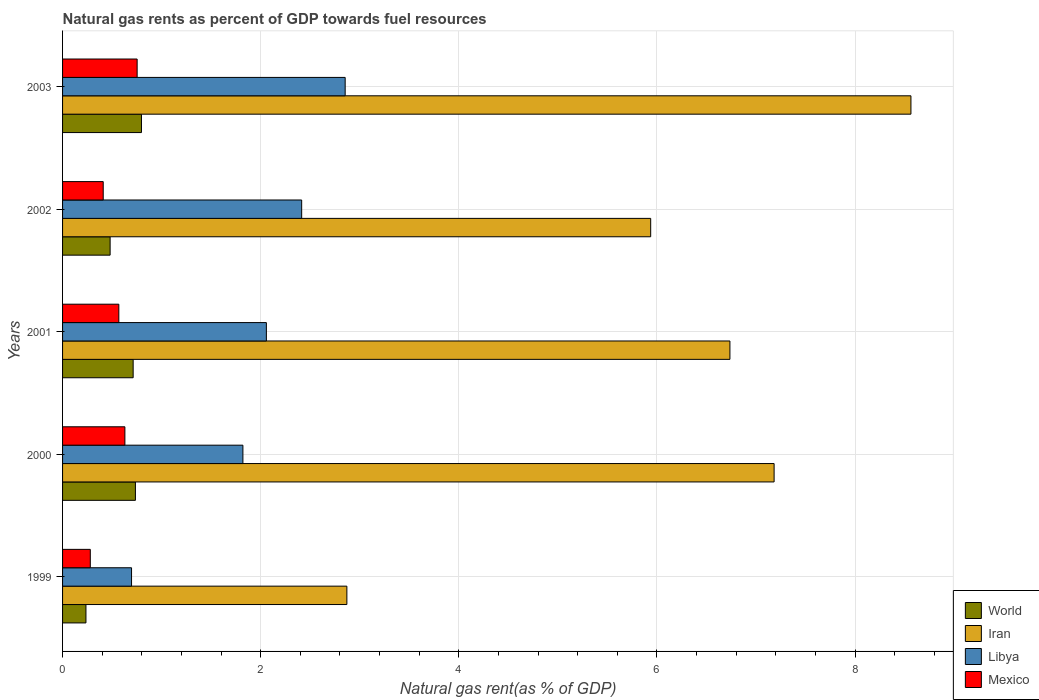Are the number of bars per tick equal to the number of legend labels?
Offer a terse response. Yes. Are the number of bars on each tick of the Y-axis equal?
Keep it short and to the point. Yes. What is the natural gas rent in Iran in 2003?
Make the answer very short. 8.56. Across all years, what is the maximum natural gas rent in Libya?
Your answer should be very brief. 2.85. Across all years, what is the minimum natural gas rent in World?
Your response must be concise. 0.24. In which year was the natural gas rent in Libya minimum?
Ensure brevity in your answer.  1999. What is the total natural gas rent in Iran in the graph?
Your answer should be compact. 31.29. What is the difference between the natural gas rent in Libya in 1999 and that in 2000?
Keep it short and to the point. -1.12. What is the difference between the natural gas rent in Libya in 2000 and the natural gas rent in World in 2001?
Offer a very short reply. 1.11. What is the average natural gas rent in World per year?
Provide a short and direct response. 0.59. In the year 2002, what is the difference between the natural gas rent in Libya and natural gas rent in Iran?
Ensure brevity in your answer.  -3.52. In how many years, is the natural gas rent in Libya greater than 4 %?
Offer a terse response. 0. What is the ratio of the natural gas rent in World in 1999 to that in 2001?
Offer a very short reply. 0.33. Is the natural gas rent in World in 2001 less than that in 2002?
Ensure brevity in your answer.  No. Is the difference between the natural gas rent in Libya in 2000 and 2002 greater than the difference between the natural gas rent in Iran in 2000 and 2002?
Give a very brief answer. No. What is the difference between the highest and the second highest natural gas rent in Iran?
Provide a succinct answer. 1.38. What is the difference between the highest and the lowest natural gas rent in Libya?
Provide a short and direct response. 2.16. Is the sum of the natural gas rent in Libya in 2000 and 2003 greater than the maximum natural gas rent in World across all years?
Make the answer very short. Yes. What does the 2nd bar from the top in 2003 represents?
Provide a short and direct response. Libya. Is it the case that in every year, the sum of the natural gas rent in Iran and natural gas rent in World is greater than the natural gas rent in Mexico?
Your answer should be very brief. Yes. How many bars are there?
Ensure brevity in your answer.  20. How many years are there in the graph?
Offer a terse response. 5. Does the graph contain any zero values?
Your answer should be very brief. No. Does the graph contain grids?
Ensure brevity in your answer.  Yes. How many legend labels are there?
Your answer should be very brief. 4. How are the legend labels stacked?
Ensure brevity in your answer.  Vertical. What is the title of the graph?
Keep it short and to the point. Natural gas rents as percent of GDP towards fuel resources. Does "Bangladesh" appear as one of the legend labels in the graph?
Your response must be concise. No. What is the label or title of the X-axis?
Keep it short and to the point. Natural gas rent(as % of GDP). What is the Natural gas rent(as % of GDP) in World in 1999?
Ensure brevity in your answer.  0.24. What is the Natural gas rent(as % of GDP) in Iran in 1999?
Your response must be concise. 2.87. What is the Natural gas rent(as % of GDP) of Libya in 1999?
Keep it short and to the point. 0.7. What is the Natural gas rent(as % of GDP) of Mexico in 1999?
Your answer should be very brief. 0.28. What is the Natural gas rent(as % of GDP) in World in 2000?
Your answer should be very brief. 0.74. What is the Natural gas rent(as % of GDP) in Iran in 2000?
Make the answer very short. 7.18. What is the Natural gas rent(as % of GDP) of Libya in 2000?
Your response must be concise. 1.82. What is the Natural gas rent(as % of GDP) in Mexico in 2000?
Give a very brief answer. 0.63. What is the Natural gas rent(as % of GDP) of World in 2001?
Your response must be concise. 0.71. What is the Natural gas rent(as % of GDP) of Iran in 2001?
Give a very brief answer. 6.74. What is the Natural gas rent(as % of GDP) of Libya in 2001?
Make the answer very short. 2.06. What is the Natural gas rent(as % of GDP) of Mexico in 2001?
Keep it short and to the point. 0.57. What is the Natural gas rent(as % of GDP) of World in 2002?
Give a very brief answer. 0.48. What is the Natural gas rent(as % of GDP) of Iran in 2002?
Keep it short and to the point. 5.94. What is the Natural gas rent(as % of GDP) of Libya in 2002?
Provide a succinct answer. 2.41. What is the Natural gas rent(as % of GDP) of Mexico in 2002?
Provide a succinct answer. 0.41. What is the Natural gas rent(as % of GDP) in World in 2003?
Provide a short and direct response. 0.8. What is the Natural gas rent(as % of GDP) of Iran in 2003?
Ensure brevity in your answer.  8.56. What is the Natural gas rent(as % of GDP) in Libya in 2003?
Ensure brevity in your answer.  2.85. What is the Natural gas rent(as % of GDP) of Mexico in 2003?
Your answer should be very brief. 0.75. Across all years, what is the maximum Natural gas rent(as % of GDP) in World?
Ensure brevity in your answer.  0.8. Across all years, what is the maximum Natural gas rent(as % of GDP) in Iran?
Your response must be concise. 8.56. Across all years, what is the maximum Natural gas rent(as % of GDP) in Libya?
Your answer should be very brief. 2.85. Across all years, what is the maximum Natural gas rent(as % of GDP) of Mexico?
Your response must be concise. 0.75. Across all years, what is the minimum Natural gas rent(as % of GDP) of World?
Your answer should be very brief. 0.24. Across all years, what is the minimum Natural gas rent(as % of GDP) in Iran?
Offer a terse response. 2.87. Across all years, what is the minimum Natural gas rent(as % of GDP) in Libya?
Your answer should be compact. 0.7. Across all years, what is the minimum Natural gas rent(as % of GDP) of Mexico?
Keep it short and to the point. 0.28. What is the total Natural gas rent(as % of GDP) of World in the graph?
Ensure brevity in your answer.  2.96. What is the total Natural gas rent(as % of GDP) of Iran in the graph?
Offer a terse response. 31.29. What is the total Natural gas rent(as % of GDP) of Libya in the graph?
Your response must be concise. 9.84. What is the total Natural gas rent(as % of GDP) of Mexico in the graph?
Make the answer very short. 2.64. What is the difference between the Natural gas rent(as % of GDP) in World in 1999 and that in 2000?
Keep it short and to the point. -0.5. What is the difference between the Natural gas rent(as % of GDP) of Iran in 1999 and that in 2000?
Make the answer very short. -4.31. What is the difference between the Natural gas rent(as % of GDP) in Libya in 1999 and that in 2000?
Keep it short and to the point. -1.12. What is the difference between the Natural gas rent(as % of GDP) of Mexico in 1999 and that in 2000?
Keep it short and to the point. -0.35. What is the difference between the Natural gas rent(as % of GDP) in World in 1999 and that in 2001?
Offer a very short reply. -0.48. What is the difference between the Natural gas rent(as % of GDP) of Iran in 1999 and that in 2001?
Give a very brief answer. -3.87. What is the difference between the Natural gas rent(as % of GDP) in Libya in 1999 and that in 2001?
Provide a succinct answer. -1.36. What is the difference between the Natural gas rent(as % of GDP) of Mexico in 1999 and that in 2001?
Give a very brief answer. -0.29. What is the difference between the Natural gas rent(as % of GDP) in World in 1999 and that in 2002?
Offer a very short reply. -0.24. What is the difference between the Natural gas rent(as % of GDP) of Iran in 1999 and that in 2002?
Your answer should be very brief. -3.07. What is the difference between the Natural gas rent(as % of GDP) in Libya in 1999 and that in 2002?
Provide a succinct answer. -1.72. What is the difference between the Natural gas rent(as % of GDP) of Mexico in 1999 and that in 2002?
Provide a short and direct response. -0.13. What is the difference between the Natural gas rent(as % of GDP) of World in 1999 and that in 2003?
Make the answer very short. -0.56. What is the difference between the Natural gas rent(as % of GDP) of Iran in 1999 and that in 2003?
Your response must be concise. -5.69. What is the difference between the Natural gas rent(as % of GDP) of Libya in 1999 and that in 2003?
Give a very brief answer. -2.16. What is the difference between the Natural gas rent(as % of GDP) of Mexico in 1999 and that in 2003?
Provide a succinct answer. -0.47. What is the difference between the Natural gas rent(as % of GDP) in World in 2000 and that in 2001?
Ensure brevity in your answer.  0.02. What is the difference between the Natural gas rent(as % of GDP) in Iran in 2000 and that in 2001?
Keep it short and to the point. 0.45. What is the difference between the Natural gas rent(as % of GDP) of Libya in 2000 and that in 2001?
Ensure brevity in your answer.  -0.24. What is the difference between the Natural gas rent(as % of GDP) of Mexico in 2000 and that in 2001?
Offer a terse response. 0.06. What is the difference between the Natural gas rent(as % of GDP) of World in 2000 and that in 2002?
Offer a very short reply. 0.26. What is the difference between the Natural gas rent(as % of GDP) in Iran in 2000 and that in 2002?
Ensure brevity in your answer.  1.25. What is the difference between the Natural gas rent(as % of GDP) in Libya in 2000 and that in 2002?
Your answer should be very brief. -0.59. What is the difference between the Natural gas rent(as % of GDP) of Mexico in 2000 and that in 2002?
Offer a terse response. 0.22. What is the difference between the Natural gas rent(as % of GDP) of World in 2000 and that in 2003?
Offer a terse response. -0.06. What is the difference between the Natural gas rent(as % of GDP) in Iran in 2000 and that in 2003?
Your response must be concise. -1.38. What is the difference between the Natural gas rent(as % of GDP) of Libya in 2000 and that in 2003?
Your answer should be compact. -1.03. What is the difference between the Natural gas rent(as % of GDP) in Mexico in 2000 and that in 2003?
Offer a terse response. -0.12. What is the difference between the Natural gas rent(as % of GDP) of World in 2001 and that in 2002?
Your answer should be compact. 0.23. What is the difference between the Natural gas rent(as % of GDP) in Iran in 2001 and that in 2002?
Give a very brief answer. 0.8. What is the difference between the Natural gas rent(as % of GDP) of Libya in 2001 and that in 2002?
Your answer should be compact. -0.36. What is the difference between the Natural gas rent(as % of GDP) of Mexico in 2001 and that in 2002?
Offer a very short reply. 0.16. What is the difference between the Natural gas rent(as % of GDP) in World in 2001 and that in 2003?
Provide a succinct answer. -0.08. What is the difference between the Natural gas rent(as % of GDP) in Iran in 2001 and that in 2003?
Make the answer very short. -1.83. What is the difference between the Natural gas rent(as % of GDP) of Libya in 2001 and that in 2003?
Give a very brief answer. -0.8. What is the difference between the Natural gas rent(as % of GDP) in Mexico in 2001 and that in 2003?
Keep it short and to the point. -0.18. What is the difference between the Natural gas rent(as % of GDP) of World in 2002 and that in 2003?
Offer a terse response. -0.32. What is the difference between the Natural gas rent(as % of GDP) in Iran in 2002 and that in 2003?
Keep it short and to the point. -2.63. What is the difference between the Natural gas rent(as % of GDP) of Libya in 2002 and that in 2003?
Provide a short and direct response. -0.44. What is the difference between the Natural gas rent(as % of GDP) in Mexico in 2002 and that in 2003?
Offer a very short reply. -0.34. What is the difference between the Natural gas rent(as % of GDP) of World in 1999 and the Natural gas rent(as % of GDP) of Iran in 2000?
Your answer should be very brief. -6.95. What is the difference between the Natural gas rent(as % of GDP) of World in 1999 and the Natural gas rent(as % of GDP) of Libya in 2000?
Provide a short and direct response. -1.58. What is the difference between the Natural gas rent(as % of GDP) in World in 1999 and the Natural gas rent(as % of GDP) in Mexico in 2000?
Ensure brevity in your answer.  -0.39. What is the difference between the Natural gas rent(as % of GDP) of Iran in 1999 and the Natural gas rent(as % of GDP) of Libya in 2000?
Ensure brevity in your answer.  1.05. What is the difference between the Natural gas rent(as % of GDP) of Iran in 1999 and the Natural gas rent(as % of GDP) of Mexico in 2000?
Ensure brevity in your answer.  2.24. What is the difference between the Natural gas rent(as % of GDP) in Libya in 1999 and the Natural gas rent(as % of GDP) in Mexico in 2000?
Keep it short and to the point. 0.07. What is the difference between the Natural gas rent(as % of GDP) in World in 1999 and the Natural gas rent(as % of GDP) in Iran in 2001?
Keep it short and to the point. -6.5. What is the difference between the Natural gas rent(as % of GDP) of World in 1999 and the Natural gas rent(as % of GDP) of Libya in 2001?
Your response must be concise. -1.82. What is the difference between the Natural gas rent(as % of GDP) of World in 1999 and the Natural gas rent(as % of GDP) of Mexico in 2001?
Ensure brevity in your answer.  -0.33. What is the difference between the Natural gas rent(as % of GDP) of Iran in 1999 and the Natural gas rent(as % of GDP) of Libya in 2001?
Give a very brief answer. 0.81. What is the difference between the Natural gas rent(as % of GDP) in Iran in 1999 and the Natural gas rent(as % of GDP) in Mexico in 2001?
Your answer should be very brief. 2.3. What is the difference between the Natural gas rent(as % of GDP) of Libya in 1999 and the Natural gas rent(as % of GDP) of Mexico in 2001?
Provide a succinct answer. 0.13. What is the difference between the Natural gas rent(as % of GDP) of World in 1999 and the Natural gas rent(as % of GDP) of Iran in 2002?
Make the answer very short. -5.7. What is the difference between the Natural gas rent(as % of GDP) of World in 1999 and the Natural gas rent(as % of GDP) of Libya in 2002?
Give a very brief answer. -2.18. What is the difference between the Natural gas rent(as % of GDP) of World in 1999 and the Natural gas rent(as % of GDP) of Mexico in 2002?
Provide a short and direct response. -0.17. What is the difference between the Natural gas rent(as % of GDP) of Iran in 1999 and the Natural gas rent(as % of GDP) of Libya in 2002?
Offer a very short reply. 0.46. What is the difference between the Natural gas rent(as % of GDP) of Iran in 1999 and the Natural gas rent(as % of GDP) of Mexico in 2002?
Your response must be concise. 2.46. What is the difference between the Natural gas rent(as % of GDP) in Libya in 1999 and the Natural gas rent(as % of GDP) in Mexico in 2002?
Ensure brevity in your answer.  0.29. What is the difference between the Natural gas rent(as % of GDP) in World in 1999 and the Natural gas rent(as % of GDP) in Iran in 2003?
Keep it short and to the point. -8.33. What is the difference between the Natural gas rent(as % of GDP) in World in 1999 and the Natural gas rent(as % of GDP) in Libya in 2003?
Offer a very short reply. -2.62. What is the difference between the Natural gas rent(as % of GDP) of World in 1999 and the Natural gas rent(as % of GDP) of Mexico in 2003?
Provide a short and direct response. -0.52. What is the difference between the Natural gas rent(as % of GDP) of Iran in 1999 and the Natural gas rent(as % of GDP) of Libya in 2003?
Ensure brevity in your answer.  0.02. What is the difference between the Natural gas rent(as % of GDP) in Iran in 1999 and the Natural gas rent(as % of GDP) in Mexico in 2003?
Offer a terse response. 2.12. What is the difference between the Natural gas rent(as % of GDP) of Libya in 1999 and the Natural gas rent(as % of GDP) of Mexico in 2003?
Your answer should be compact. -0.06. What is the difference between the Natural gas rent(as % of GDP) of World in 2000 and the Natural gas rent(as % of GDP) of Iran in 2001?
Offer a very short reply. -6. What is the difference between the Natural gas rent(as % of GDP) of World in 2000 and the Natural gas rent(as % of GDP) of Libya in 2001?
Ensure brevity in your answer.  -1.32. What is the difference between the Natural gas rent(as % of GDP) of World in 2000 and the Natural gas rent(as % of GDP) of Mexico in 2001?
Keep it short and to the point. 0.17. What is the difference between the Natural gas rent(as % of GDP) of Iran in 2000 and the Natural gas rent(as % of GDP) of Libya in 2001?
Keep it short and to the point. 5.13. What is the difference between the Natural gas rent(as % of GDP) of Iran in 2000 and the Natural gas rent(as % of GDP) of Mexico in 2001?
Make the answer very short. 6.62. What is the difference between the Natural gas rent(as % of GDP) of Libya in 2000 and the Natural gas rent(as % of GDP) of Mexico in 2001?
Your answer should be compact. 1.25. What is the difference between the Natural gas rent(as % of GDP) in World in 2000 and the Natural gas rent(as % of GDP) in Iran in 2002?
Give a very brief answer. -5.2. What is the difference between the Natural gas rent(as % of GDP) of World in 2000 and the Natural gas rent(as % of GDP) of Libya in 2002?
Provide a succinct answer. -1.68. What is the difference between the Natural gas rent(as % of GDP) in World in 2000 and the Natural gas rent(as % of GDP) in Mexico in 2002?
Provide a short and direct response. 0.33. What is the difference between the Natural gas rent(as % of GDP) in Iran in 2000 and the Natural gas rent(as % of GDP) in Libya in 2002?
Your answer should be compact. 4.77. What is the difference between the Natural gas rent(as % of GDP) of Iran in 2000 and the Natural gas rent(as % of GDP) of Mexico in 2002?
Offer a very short reply. 6.77. What is the difference between the Natural gas rent(as % of GDP) in Libya in 2000 and the Natural gas rent(as % of GDP) in Mexico in 2002?
Offer a terse response. 1.41. What is the difference between the Natural gas rent(as % of GDP) in World in 2000 and the Natural gas rent(as % of GDP) in Iran in 2003?
Your response must be concise. -7.83. What is the difference between the Natural gas rent(as % of GDP) of World in 2000 and the Natural gas rent(as % of GDP) of Libya in 2003?
Offer a terse response. -2.12. What is the difference between the Natural gas rent(as % of GDP) in World in 2000 and the Natural gas rent(as % of GDP) in Mexico in 2003?
Keep it short and to the point. -0.02. What is the difference between the Natural gas rent(as % of GDP) in Iran in 2000 and the Natural gas rent(as % of GDP) in Libya in 2003?
Ensure brevity in your answer.  4.33. What is the difference between the Natural gas rent(as % of GDP) of Iran in 2000 and the Natural gas rent(as % of GDP) of Mexico in 2003?
Keep it short and to the point. 6.43. What is the difference between the Natural gas rent(as % of GDP) of Libya in 2000 and the Natural gas rent(as % of GDP) of Mexico in 2003?
Your answer should be very brief. 1.07. What is the difference between the Natural gas rent(as % of GDP) in World in 2001 and the Natural gas rent(as % of GDP) in Iran in 2002?
Keep it short and to the point. -5.22. What is the difference between the Natural gas rent(as % of GDP) of World in 2001 and the Natural gas rent(as % of GDP) of Libya in 2002?
Provide a short and direct response. -1.7. What is the difference between the Natural gas rent(as % of GDP) in World in 2001 and the Natural gas rent(as % of GDP) in Mexico in 2002?
Give a very brief answer. 0.3. What is the difference between the Natural gas rent(as % of GDP) of Iran in 2001 and the Natural gas rent(as % of GDP) of Libya in 2002?
Ensure brevity in your answer.  4.32. What is the difference between the Natural gas rent(as % of GDP) of Iran in 2001 and the Natural gas rent(as % of GDP) of Mexico in 2002?
Offer a very short reply. 6.33. What is the difference between the Natural gas rent(as % of GDP) of Libya in 2001 and the Natural gas rent(as % of GDP) of Mexico in 2002?
Keep it short and to the point. 1.65. What is the difference between the Natural gas rent(as % of GDP) of World in 2001 and the Natural gas rent(as % of GDP) of Iran in 2003?
Give a very brief answer. -7.85. What is the difference between the Natural gas rent(as % of GDP) of World in 2001 and the Natural gas rent(as % of GDP) of Libya in 2003?
Make the answer very short. -2.14. What is the difference between the Natural gas rent(as % of GDP) of World in 2001 and the Natural gas rent(as % of GDP) of Mexico in 2003?
Your response must be concise. -0.04. What is the difference between the Natural gas rent(as % of GDP) in Iran in 2001 and the Natural gas rent(as % of GDP) in Libya in 2003?
Offer a terse response. 3.88. What is the difference between the Natural gas rent(as % of GDP) in Iran in 2001 and the Natural gas rent(as % of GDP) in Mexico in 2003?
Provide a short and direct response. 5.98. What is the difference between the Natural gas rent(as % of GDP) in Libya in 2001 and the Natural gas rent(as % of GDP) in Mexico in 2003?
Provide a succinct answer. 1.3. What is the difference between the Natural gas rent(as % of GDP) in World in 2002 and the Natural gas rent(as % of GDP) in Iran in 2003?
Your response must be concise. -8.08. What is the difference between the Natural gas rent(as % of GDP) in World in 2002 and the Natural gas rent(as % of GDP) in Libya in 2003?
Give a very brief answer. -2.37. What is the difference between the Natural gas rent(as % of GDP) in World in 2002 and the Natural gas rent(as % of GDP) in Mexico in 2003?
Your answer should be compact. -0.27. What is the difference between the Natural gas rent(as % of GDP) of Iran in 2002 and the Natural gas rent(as % of GDP) of Libya in 2003?
Your answer should be compact. 3.08. What is the difference between the Natural gas rent(as % of GDP) in Iran in 2002 and the Natural gas rent(as % of GDP) in Mexico in 2003?
Keep it short and to the point. 5.18. What is the difference between the Natural gas rent(as % of GDP) of Libya in 2002 and the Natural gas rent(as % of GDP) of Mexico in 2003?
Your answer should be compact. 1.66. What is the average Natural gas rent(as % of GDP) in World per year?
Offer a terse response. 0.59. What is the average Natural gas rent(as % of GDP) in Iran per year?
Provide a succinct answer. 6.26. What is the average Natural gas rent(as % of GDP) of Libya per year?
Offer a terse response. 1.97. What is the average Natural gas rent(as % of GDP) of Mexico per year?
Provide a short and direct response. 0.53. In the year 1999, what is the difference between the Natural gas rent(as % of GDP) in World and Natural gas rent(as % of GDP) in Iran?
Your answer should be very brief. -2.63. In the year 1999, what is the difference between the Natural gas rent(as % of GDP) of World and Natural gas rent(as % of GDP) of Libya?
Your response must be concise. -0.46. In the year 1999, what is the difference between the Natural gas rent(as % of GDP) in World and Natural gas rent(as % of GDP) in Mexico?
Your answer should be very brief. -0.04. In the year 1999, what is the difference between the Natural gas rent(as % of GDP) of Iran and Natural gas rent(as % of GDP) of Libya?
Your answer should be compact. 2.17. In the year 1999, what is the difference between the Natural gas rent(as % of GDP) in Iran and Natural gas rent(as % of GDP) in Mexico?
Your answer should be compact. 2.59. In the year 1999, what is the difference between the Natural gas rent(as % of GDP) of Libya and Natural gas rent(as % of GDP) of Mexico?
Your answer should be compact. 0.42. In the year 2000, what is the difference between the Natural gas rent(as % of GDP) in World and Natural gas rent(as % of GDP) in Iran?
Your answer should be compact. -6.45. In the year 2000, what is the difference between the Natural gas rent(as % of GDP) in World and Natural gas rent(as % of GDP) in Libya?
Give a very brief answer. -1.08. In the year 2000, what is the difference between the Natural gas rent(as % of GDP) of World and Natural gas rent(as % of GDP) of Mexico?
Offer a terse response. 0.11. In the year 2000, what is the difference between the Natural gas rent(as % of GDP) in Iran and Natural gas rent(as % of GDP) in Libya?
Give a very brief answer. 5.36. In the year 2000, what is the difference between the Natural gas rent(as % of GDP) of Iran and Natural gas rent(as % of GDP) of Mexico?
Your answer should be very brief. 6.55. In the year 2000, what is the difference between the Natural gas rent(as % of GDP) of Libya and Natural gas rent(as % of GDP) of Mexico?
Offer a very short reply. 1.19. In the year 2001, what is the difference between the Natural gas rent(as % of GDP) of World and Natural gas rent(as % of GDP) of Iran?
Offer a terse response. -6.02. In the year 2001, what is the difference between the Natural gas rent(as % of GDP) of World and Natural gas rent(as % of GDP) of Libya?
Your answer should be compact. -1.34. In the year 2001, what is the difference between the Natural gas rent(as % of GDP) in World and Natural gas rent(as % of GDP) in Mexico?
Provide a succinct answer. 0.14. In the year 2001, what is the difference between the Natural gas rent(as % of GDP) of Iran and Natural gas rent(as % of GDP) of Libya?
Offer a terse response. 4.68. In the year 2001, what is the difference between the Natural gas rent(as % of GDP) in Iran and Natural gas rent(as % of GDP) in Mexico?
Make the answer very short. 6.17. In the year 2001, what is the difference between the Natural gas rent(as % of GDP) in Libya and Natural gas rent(as % of GDP) in Mexico?
Keep it short and to the point. 1.49. In the year 2002, what is the difference between the Natural gas rent(as % of GDP) in World and Natural gas rent(as % of GDP) in Iran?
Make the answer very short. -5.46. In the year 2002, what is the difference between the Natural gas rent(as % of GDP) in World and Natural gas rent(as % of GDP) in Libya?
Provide a succinct answer. -1.93. In the year 2002, what is the difference between the Natural gas rent(as % of GDP) in World and Natural gas rent(as % of GDP) in Mexico?
Keep it short and to the point. 0.07. In the year 2002, what is the difference between the Natural gas rent(as % of GDP) in Iran and Natural gas rent(as % of GDP) in Libya?
Provide a succinct answer. 3.52. In the year 2002, what is the difference between the Natural gas rent(as % of GDP) of Iran and Natural gas rent(as % of GDP) of Mexico?
Provide a succinct answer. 5.53. In the year 2002, what is the difference between the Natural gas rent(as % of GDP) of Libya and Natural gas rent(as % of GDP) of Mexico?
Provide a short and direct response. 2. In the year 2003, what is the difference between the Natural gas rent(as % of GDP) of World and Natural gas rent(as % of GDP) of Iran?
Make the answer very short. -7.77. In the year 2003, what is the difference between the Natural gas rent(as % of GDP) of World and Natural gas rent(as % of GDP) of Libya?
Keep it short and to the point. -2.06. In the year 2003, what is the difference between the Natural gas rent(as % of GDP) of World and Natural gas rent(as % of GDP) of Mexico?
Offer a terse response. 0.04. In the year 2003, what is the difference between the Natural gas rent(as % of GDP) of Iran and Natural gas rent(as % of GDP) of Libya?
Keep it short and to the point. 5.71. In the year 2003, what is the difference between the Natural gas rent(as % of GDP) in Iran and Natural gas rent(as % of GDP) in Mexico?
Your answer should be compact. 7.81. In the year 2003, what is the difference between the Natural gas rent(as % of GDP) in Libya and Natural gas rent(as % of GDP) in Mexico?
Offer a terse response. 2.1. What is the ratio of the Natural gas rent(as % of GDP) in World in 1999 to that in 2000?
Provide a succinct answer. 0.32. What is the ratio of the Natural gas rent(as % of GDP) of Iran in 1999 to that in 2000?
Your answer should be very brief. 0.4. What is the ratio of the Natural gas rent(as % of GDP) in Libya in 1999 to that in 2000?
Keep it short and to the point. 0.38. What is the ratio of the Natural gas rent(as % of GDP) of Mexico in 1999 to that in 2000?
Your answer should be compact. 0.45. What is the ratio of the Natural gas rent(as % of GDP) of World in 1999 to that in 2001?
Your response must be concise. 0.33. What is the ratio of the Natural gas rent(as % of GDP) in Iran in 1999 to that in 2001?
Make the answer very short. 0.43. What is the ratio of the Natural gas rent(as % of GDP) of Libya in 1999 to that in 2001?
Your response must be concise. 0.34. What is the ratio of the Natural gas rent(as % of GDP) in Mexico in 1999 to that in 2001?
Your answer should be compact. 0.49. What is the ratio of the Natural gas rent(as % of GDP) of World in 1999 to that in 2002?
Give a very brief answer. 0.49. What is the ratio of the Natural gas rent(as % of GDP) of Iran in 1999 to that in 2002?
Make the answer very short. 0.48. What is the ratio of the Natural gas rent(as % of GDP) in Libya in 1999 to that in 2002?
Give a very brief answer. 0.29. What is the ratio of the Natural gas rent(as % of GDP) in Mexico in 1999 to that in 2002?
Keep it short and to the point. 0.68. What is the ratio of the Natural gas rent(as % of GDP) of World in 1999 to that in 2003?
Your answer should be very brief. 0.3. What is the ratio of the Natural gas rent(as % of GDP) in Iran in 1999 to that in 2003?
Make the answer very short. 0.34. What is the ratio of the Natural gas rent(as % of GDP) in Libya in 1999 to that in 2003?
Ensure brevity in your answer.  0.24. What is the ratio of the Natural gas rent(as % of GDP) of Mexico in 1999 to that in 2003?
Your answer should be very brief. 0.37. What is the ratio of the Natural gas rent(as % of GDP) of World in 2000 to that in 2001?
Offer a very short reply. 1.03. What is the ratio of the Natural gas rent(as % of GDP) in Iran in 2000 to that in 2001?
Give a very brief answer. 1.07. What is the ratio of the Natural gas rent(as % of GDP) of Libya in 2000 to that in 2001?
Provide a succinct answer. 0.88. What is the ratio of the Natural gas rent(as % of GDP) of Mexico in 2000 to that in 2001?
Offer a very short reply. 1.11. What is the ratio of the Natural gas rent(as % of GDP) of World in 2000 to that in 2002?
Your response must be concise. 1.53. What is the ratio of the Natural gas rent(as % of GDP) in Iran in 2000 to that in 2002?
Give a very brief answer. 1.21. What is the ratio of the Natural gas rent(as % of GDP) of Libya in 2000 to that in 2002?
Offer a very short reply. 0.75. What is the ratio of the Natural gas rent(as % of GDP) of Mexico in 2000 to that in 2002?
Keep it short and to the point. 1.53. What is the ratio of the Natural gas rent(as % of GDP) in World in 2000 to that in 2003?
Provide a succinct answer. 0.92. What is the ratio of the Natural gas rent(as % of GDP) in Iran in 2000 to that in 2003?
Offer a terse response. 0.84. What is the ratio of the Natural gas rent(as % of GDP) of Libya in 2000 to that in 2003?
Your answer should be very brief. 0.64. What is the ratio of the Natural gas rent(as % of GDP) in Mexico in 2000 to that in 2003?
Ensure brevity in your answer.  0.84. What is the ratio of the Natural gas rent(as % of GDP) of World in 2001 to that in 2002?
Make the answer very short. 1.48. What is the ratio of the Natural gas rent(as % of GDP) of Iran in 2001 to that in 2002?
Provide a succinct answer. 1.13. What is the ratio of the Natural gas rent(as % of GDP) in Libya in 2001 to that in 2002?
Offer a very short reply. 0.85. What is the ratio of the Natural gas rent(as % of GDP) of Mexico in 2001 to that in 2002?
Provide a short and direct response. 1.38. What is the ratio of the Natural gas rent(as % of GDP) in World in 2001 to that in 2003?
Keep it short and to the point. 0.89. What is the ratio of the Natural gas rent(as % of GDP) in Iran in 2001 to that in 2003?
Offer a terse response. 0.79. What is the ratio of the Natural gas rent(as % of GDP) in Libya in 2001 to that in 2003?
Ensure brevity in your answer.  0.72. What is the ratio of the Natural gas rent(as % of GDP) of Mexico in 2001 to that in 2003?
Offer a terse response. 0.75. What is the ratio of the Natural gas rent(as % of GDP) of World in 2002 to that in 2003?
Offer a very short reply. 0.6. What is the ratio of the Natural gas rent(as % of GDP) of Iran in 2002 to that in 2003?
Your response must be concise. 0.69. What is the ratio of the Natural gas rent(as % of GDP) of Libya in 2002 to that in 2003?
Provide a succinct answer. 0.85. What is the ratio of the Natural gas rent(as % of GDP) in Mexico in 2002 to that in 2003?
Give a very brief answer. 0.55. What is the difference between the highest and the second highest Natural gas rent(as % of GDP) in World?
Keep it short and to the point. 0.06. What is the difference between the highest and the second highest Natural gas rent(as % of GDP) of Iran?
Provide a short and direct response. 1.38. What is the difference between the highest and the second highest Natural gas rent(as % of GDP) of Libya?
Ensure brevity in your answer.  0.44. What is the difference between the highest and the second highest Natural gas rent(as % of GDP) of Mexico?
Give a very brief answer. 0.12. What is the difference between the highest and the lowest Natural gas rent(as % of GDP) in World?
Provide a short and direct response. 0.56. What is the difference between the highest and the lowest Natural gas rent(as % of GDP) of Iran?
Give a very brief answer. 5.69. What is the difference between the highest and the lowest Natural gas rent(as % of GDP) of Libya?
Give a very brief answer. 2.16. What is the difference between the highest and the lowest Natural gas rent(as % of GDP) of Mexico?
Offer a very short reply. 0.47. 